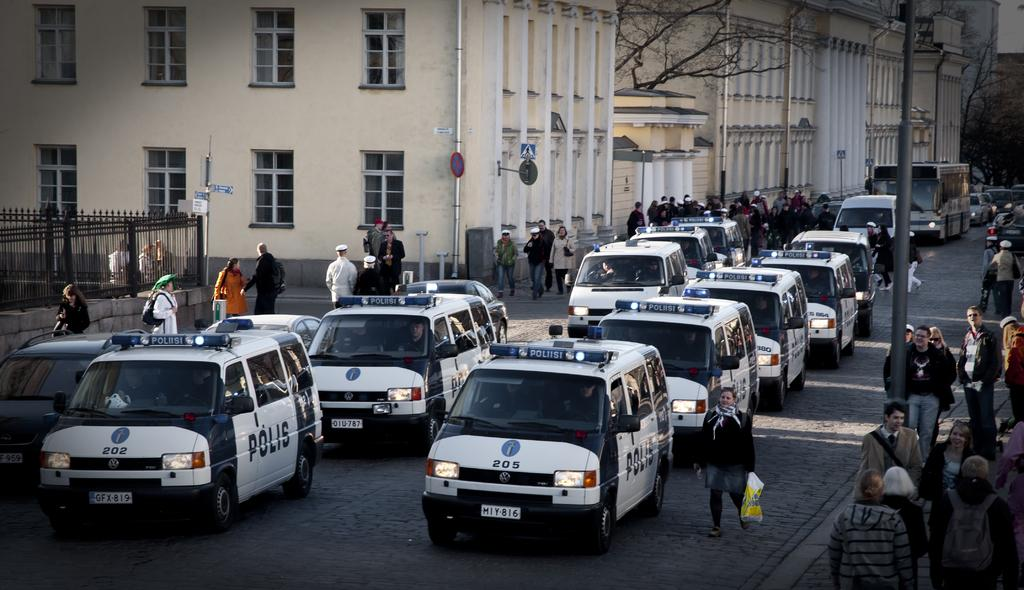<image>
Render a clear and concise summary of the photo. A row of police vehicles with flashing blue lights say Polis on the side. 